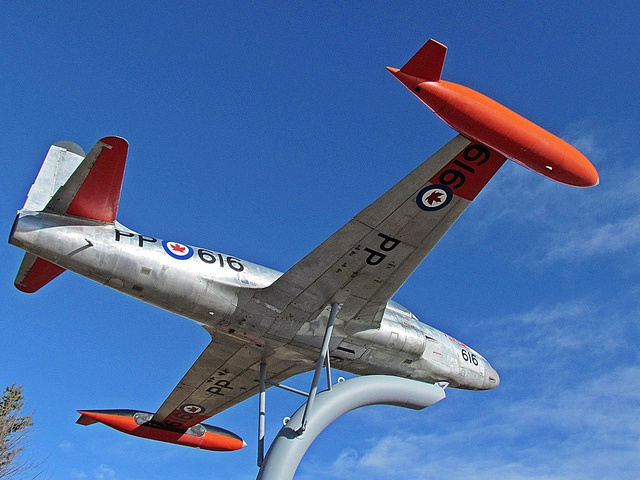Describe the objects in this image and their specific colors. I can see a airplane in blue, gray, maroon, lightgray, and black tones in this image. 